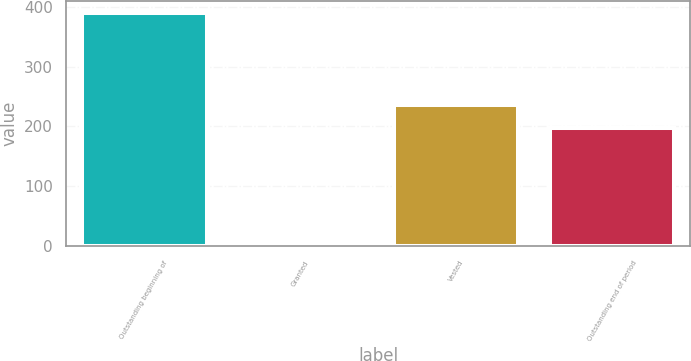Convert chart to OTSL. <chart><loc_0><loc_0><loc_500><loc_500><bar_chart><fcel>Outstanding beginning of<fcel>Granted<fcel>Vested<fcel>Outstanding end of period<nl><fcel>390<fcel>6<fcel>235.4<fcel>197<nl></chart> 